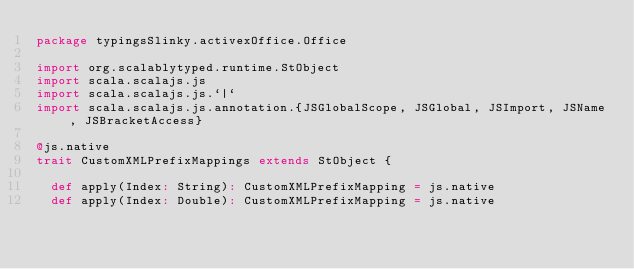Convert code to text. <code><loc_0><loc_0><loc_500><loc_500><_Scala_>package typingsSlinky.activexOffice.Office

import org.scalablytyped.runtime.StObject
import scala.scalajs.js
import scala.scalajs.js.`|`
import scala.scalajs.js.annotation.{JSGlobalScope, JSGlobal, JSImport, JSName, JSBracketAccess}

@js.native
trait CustomXMLPrefixMappings extends StObject {
  
  def apply(Index: String): CustomXMLPrefixMapping = js.native
  def apply(Index: Double): CustomXMLPrefixMapping = js.native
  </code> 